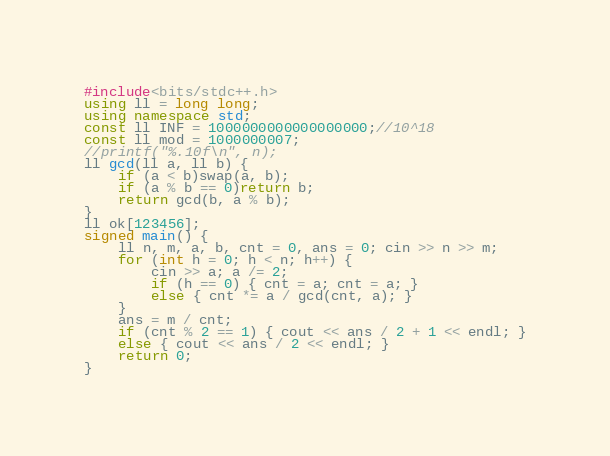Convert code to text. <code><loc_0><loc_0><loc_500><loc_500><_C++_>#include<bits/stdc++.h>
using ll = long long;
using namespace std;
const ll INF = 1000000000000000000;//10^18
const ll mod = 1000000007;
//printf("%.10f\n", n);
ll gcd(ll a, ll b) {
	if (a < b)swap(a, b);
	if (a % b == 0)return b;
	return gcd(b, a % b);
}
ll ok[123456];
signed main() {
    ll n, m, a, b, cnt = 0, ans = 0; cin >> n >> m;
	for (int h = 0; h < n; h++) {
		cin >> a; a /= 2;
		if (h == 0) { cnt = a; cnt = a; }
		else { cnt *= a / gcd(cnt, a); }
	}
	ans = m / cnt;
	if (cnt % 2 == 1) { cout << ans / 2 + 1 << endl; }
	else { cout << ans / 2 << endl; }
	return 0;
}</code> 